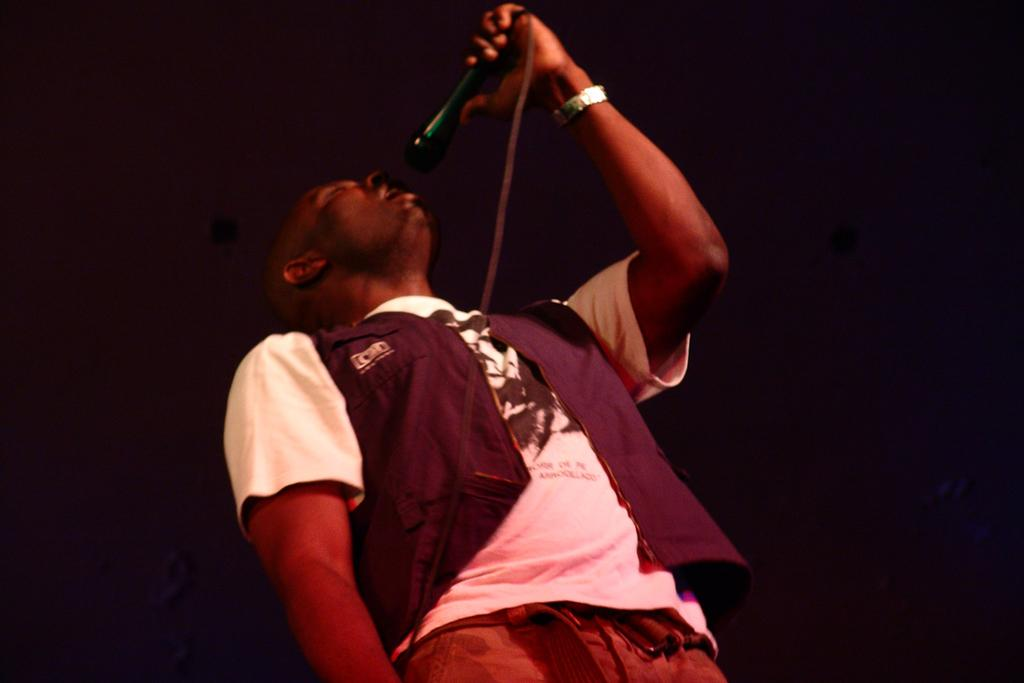Who is the main subject in the foreground of the image? There is a man in the foreground of the image. What is the man holding in the image? The man is holding a mic. What can be observed about the background of the image? The background of the image is dark. What type of frame is visible around the man in the image? There is no frame visible around the man in the image. Is the man made of wax in the image? The man is not made of wax in the image; he is a real person. 